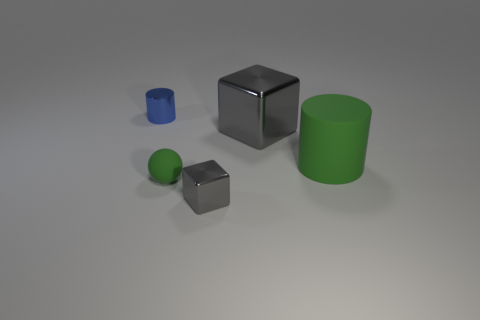What number of cylinders have the same material as the small block?
Provide a succinct answer. 1. What color is the small ball that is made of the same material as the green cylinder?
Keep it short and to the point. Green. There is a large shiny thing; what shape is it?
Your answer should be compact. Cube. What number of balls are the same color as the rubber cylinder?
Offer a very short reply. 1. What is the shape of the blue metal thing that is the same size as the ball?
Your answer should be very brief. Cylinder. Are there any balls of the same size as the blue metal cylinder?
Make the answer very short. Yes. There is a green sphere that is the same size as the blue shiny thing; what is its material?
Keep it short and to the point. Rubber. What size is the gray thing that is in front of the cylinder right of the blue metal object?
Offer a very short reply. Small. Is the size of the cylinder that is right of the blue metal cylinder the same as the large metal cube?
Keep it short and to the point. Yes. Is the number of cylinders to the right of the metal cylinder greater than the number of green cylinders that are in front of the green sphere?
Your answer should be compact. Yes. 